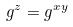<formula> <loc_0><loc_0><loc_500><loc_500>g ^ { z } = g ^ { x y }</formula> 